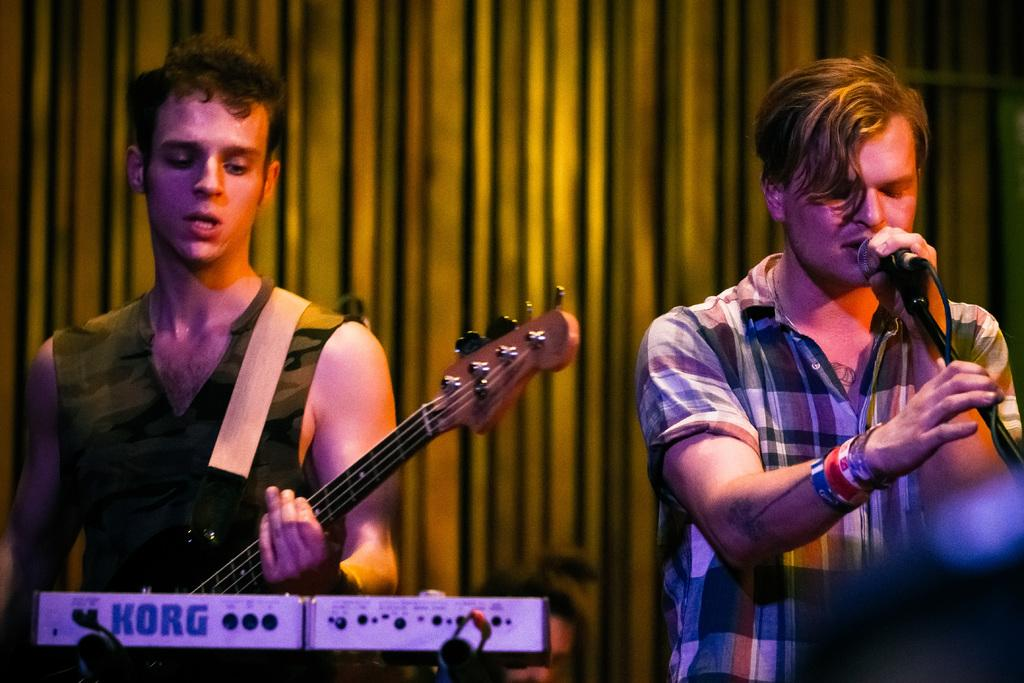How many people are in the image? There are two men in the image. What is one of the men doing in the image? One of the men is playing a guitar. What is the other man doing in the image? The other man is singing into a microphone. What type of quince can be seen in the image? There is no quince present in the image. Is the paint on the guitar visible in the image? There is no mention of paint on the guitar in the provided facts, and the image does not show any paint. 